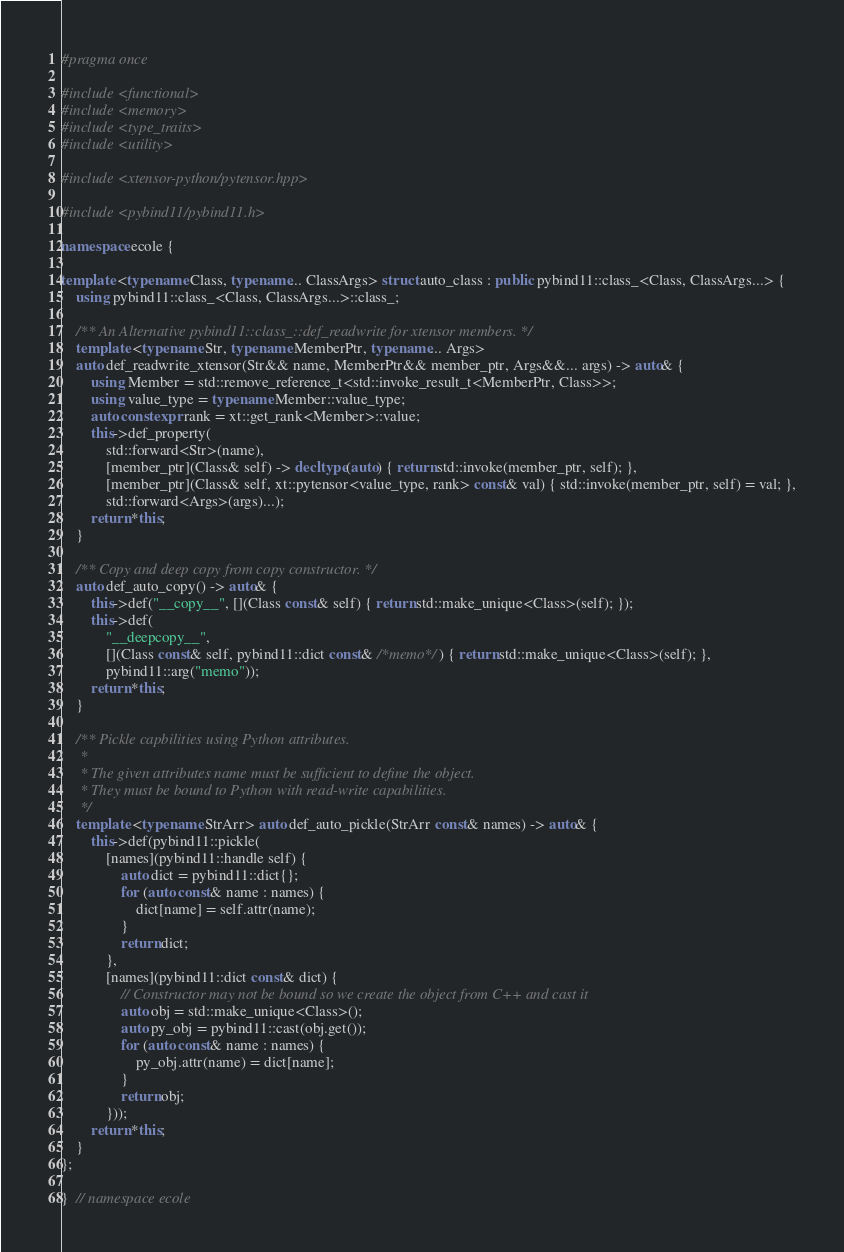<code> <loc_0><loc_0><loc_500><loc_500><_C++_>#pragma once

#include <functional>
#include <memory>
#include <type_traits>
#include <utility>

#include <xtensor-python/pytensor.hpp>

#include <pybind11/pybind11.h>

namespace ecole {

template <typename Class, typename... ClassArgs> struct auto_class : public pybind11::class_<Class, ClassArgs...> {
	using pybind11::class_<Class, ClassArgs...>::class_;

	/** An Alternative pybind11::class_::def_readwrite for xtensor members. */
	template <typename Str, typename MemberPtr, typename... Args>
	auto def_readwrite_xtensor(Str&& name, MemberPtr&& member_ptr, Args&&... args) -> auto& {
		using Member = std::remove_reference_t<std::invoke_result_t<MemberPtr, Class>>;
		using value_type = typename Member::value_type;
		auto constexpr rank = xt::get_rank<Member>::value;
		this->def_property(
			std::forward<Str>(name),
			[member_ptr](Class& self) -> decltype(auto) { return std::invoke(member_ptr, self); },
			[member_ptr](Class& self, xt::pytensor<value_type, rank> const& val) { std::invoke(member_ptr, self) = val; },
			std::forward<Args>(args)...);
		return *this;
	}

	/** Copy and deep copy from copy constructor. */
	auto def_auto_copy() -> auto& {
		this->def("__copy__", [](Class const& self) { return std::make_unique<Class>(self); });
		this->def(
			"__deepcopy__",
			[](Class const& self, pybind11::dict const& /*memo*/) { return std::make_unique<Class>(self); },
			pybind11::arg("memo"));
		return *this;
	}

	/** Pickle capbilities using Python attributes.
	 *
	 * The given attributes name must be sufficient to define the object.
	 * They must be bound to Python with read-write capabilities.
	 */
	template <typename StrArr> auto def_auto_pickle(StrArr const& names) -> auto& {
		this->def(pybind11::pickle(
			[names](pybind11::handle self) {
				auto dict = pybind11::dict{};
				for (auto const& name : names) {
					dict[name] = self.attr(name);
				}
				return dict;
			},
			[names](pybind11::dict const& dict) {
				// Constructor may not be bound so we create the object from C++ and cast it
				auto obj = std::make_unique<Class>();
				auto py_obj = pybind11::cast(obj.get());
				for (auto const& name : names) {
					py_obj.attr(name) = dict[name];
				}
				return obj;
			}));
		return *this;
	}
};

}  // namespace ecole
</code> 